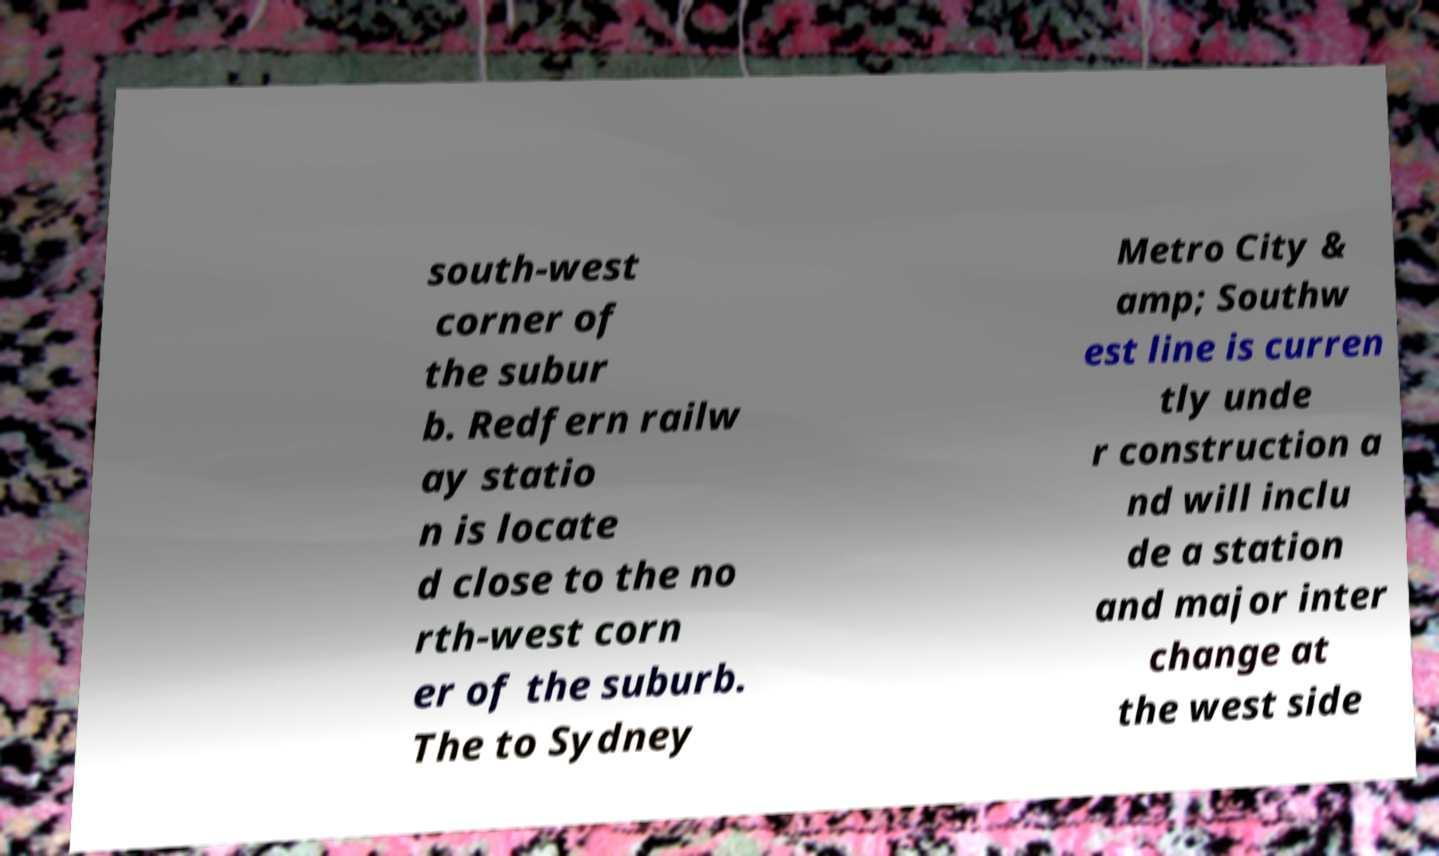Please identify and transcribe the text found in this image. south-west corner of the subur b. Redfern railw ay statio n is locate d close to the no rth-west corn er of the suburb. The to Sydney Metro City & amp; Southw est line is curren tly unde r construction a nd will inclu de a station and major inter change at the west side 